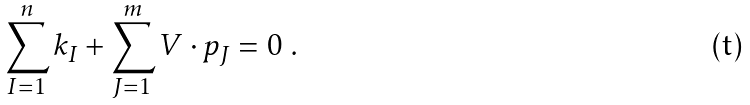Convert formula to latex. <formula><loc_0><loc_0><loc_500><loc_500>\sum _ { I = 1 } ^ { n } k _ { I } + \sum _ { J = 1 } ^ { m } V \cdot p _ { J } = 0 \ .</formula> 